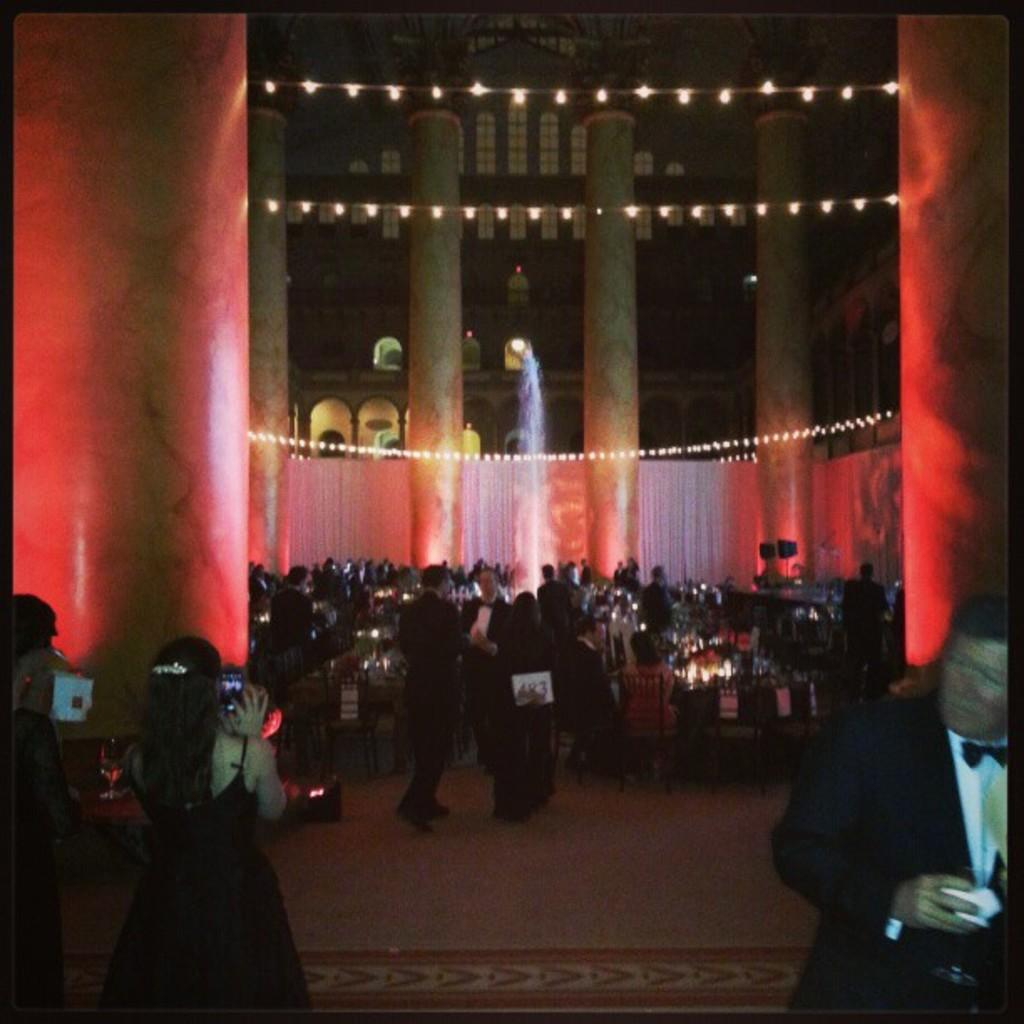How many people are in the image? There is a group of people in the image, but the exact number is not specified. What are some of the people in the image doing? Some people are standing, and some people are walking. What can be seen in the background of the image? There are white curtains visible in the background. What can be seen illuminating the scene in the image? There are lights visible in the image. What type of table is being used by the people in the image? There is no table present in the image; the people are standing or walking. How much credit is being given to the person in the image? The concept of credit is not applicable in this context, as the image does not depict a financial transaction or any situation where credit would be relevant. 